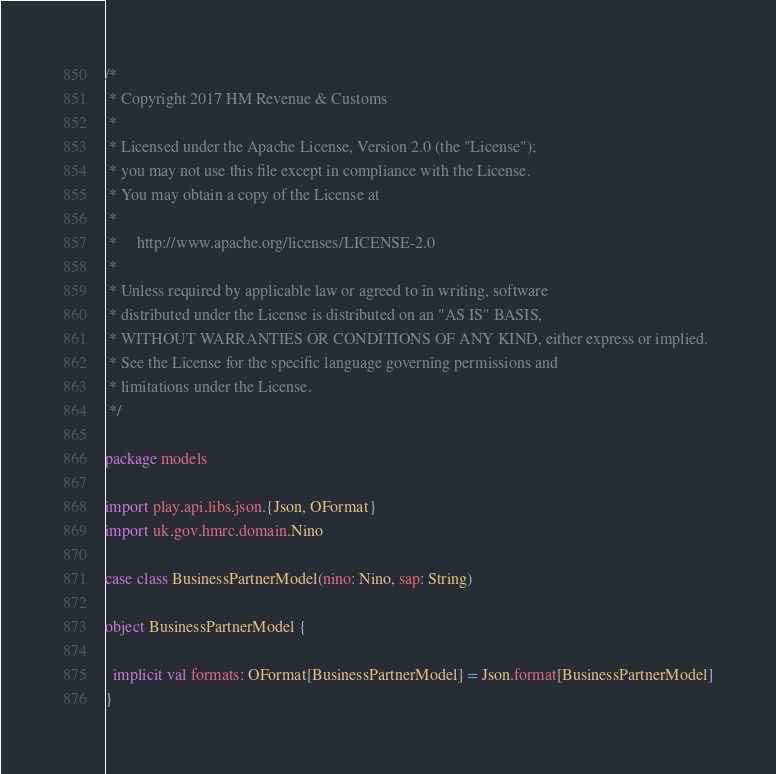Convert code to text. <code><loc_0><loc_0><loc_500><loc_500><_Scala_>/*
 * Copyright 2017 HM Revenue & Customs
 *
 * Licensed under the Apache License, Version 2.0 (the "License");
 * you may not use this file except in compliance with the License.
 * You may obtain a copy of the License at
 *
 *     http://www.apache.org/licenses/LICENSE-2.0
 *
 * Unless required by applicable law or agreed to in writing, software
 * distributed under the License is distributed on an "AS IS" BASIS,
 * WITHOUT WARRANTIES OR CONDITIONS OF ANY KIND, either express or implied.
 * See the License for the specific language governing permissions and
 * limitations under the License.
 */

package models

import play.api.libs.json.{Json, OFormat}
import uk.gov.hmrc.domain.Nino

case class BusinessPartnerModel(nino: Nino, sap: String)

object BusinessPartnerModel {

  implicit val formats: OFormat[BusinessPartnerModel] = Json.format[BusinessPartnerModel]
}
</code> 